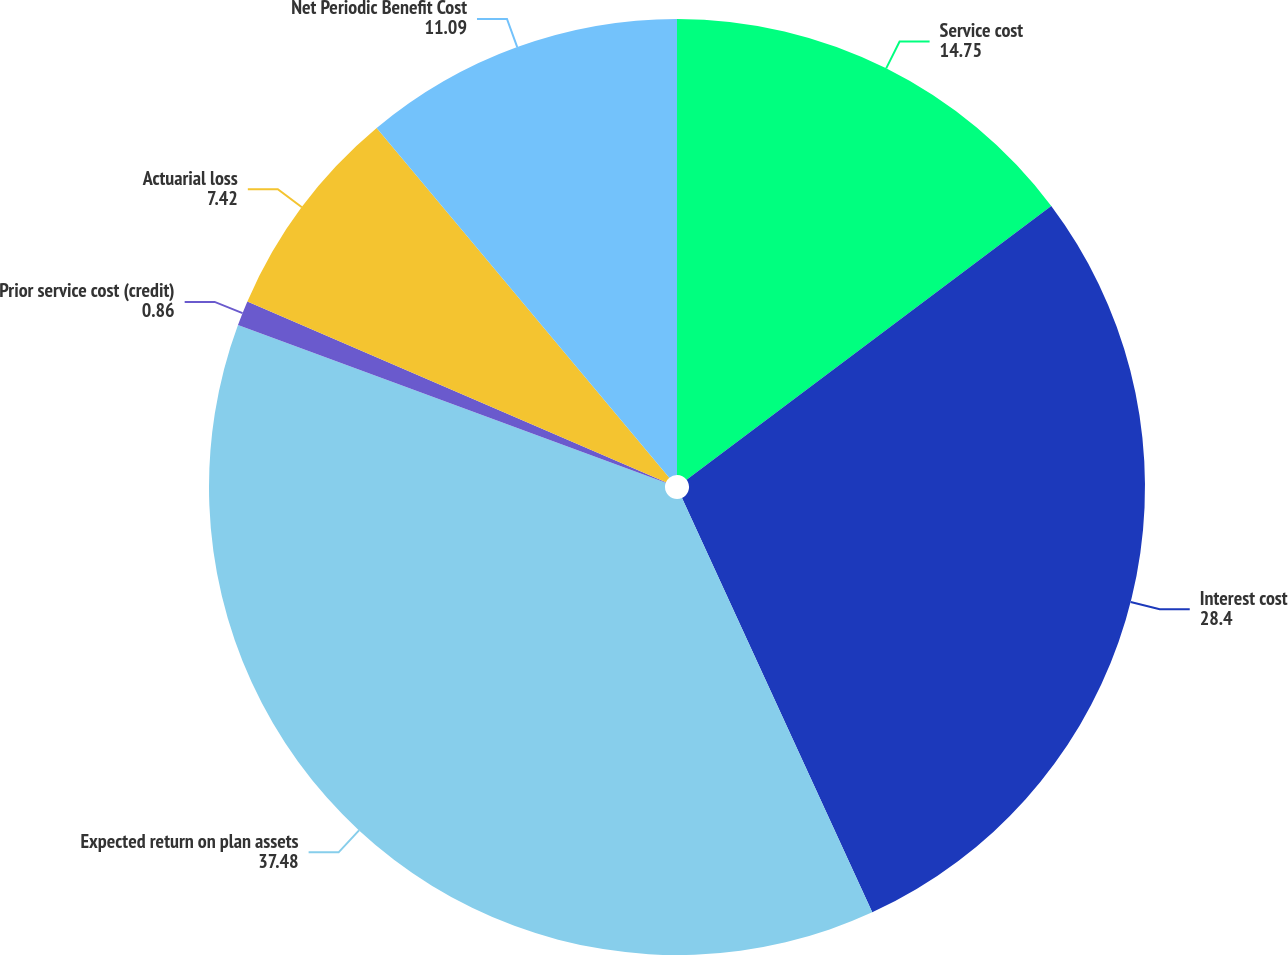Convert chart to OTSL. <chart><loc_0><loc_0><loc_500><loc_500><pie_chart><fcel>Service cost<fcel>Interest cost<fcel>Expected return on plan assets<fcel>Prior service cost (credit)<fcel>Actuarial loss<fcel>Net Periodic Benefit Cost<nl><fcel>14.75%<fcel>28.4%<fcel>37.48%<fcel>0.86%<fcel>7.42%<fcel>11.09%<nl></chart> 